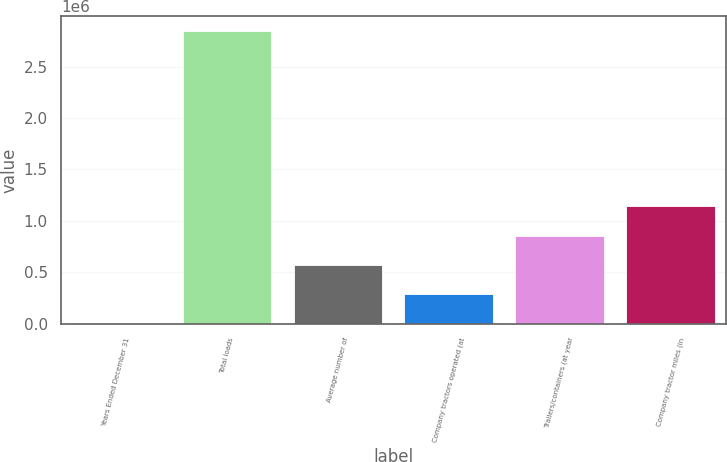Convert chart to OTSL. <chart><loc_0><loc_0><loc_500><loc_500><bar_chart><fcel>Years Ended December 31<fcel>Total loads<fcel>Average number of<fcel>Company tractors operated (at<fcel>Trailers/containers (at year<fcel>Company tractor miles (in<nl><fcel>2002<fcel>2.84738e+06<fcel>571077<fcel>286540<fcel>855614<fcel>1.14015e+06<nl></chart> 